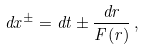Convert formula to latex. <formula><loc_0><loc_0><loc_500><loc_500>d x ^ { \pm } = d t \pm \frac { d r } { F ( r ) } \, ,</formula> 